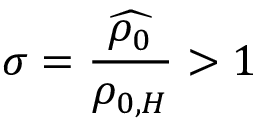Convert formula to latex. <formula><loc_0><loc_0><loc_500><loc_500>\sigma = \frac { \widehat { \rho _ { 0 } } } { \rho _ { 0 , H } } > 1</formula> 